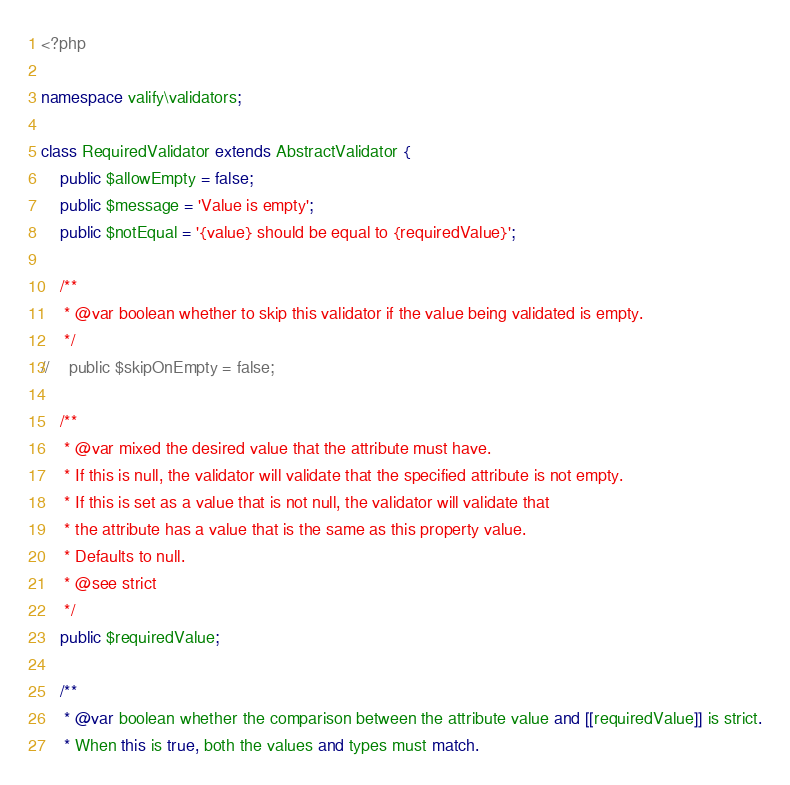<code> <loc_0><loc_0><loc_500><loc_500><_PHP_><?php

namespace valify\validators;

class RequiredValidator extends AbstractValidator {
    public $allowEmpty = false;
    public $message = 'Value is empty';
    public $notEqual = '{value} should be equal to {requiredValue}';

    /**
     * @var boolean whether to skip this validator if the value being validated is empty.
     */
//    public $skipOnEmpty = false;

    /**
     * @var mixed the desired value that the attribute must have.
     * If this is null, the validator will validate that the specified attribute is not empty.
     * If this is set as a value that is not null, the validator will validate that
     * the attribute has a value that is the same as this property value.
     * Defaults to null.
     * @see strict
     */
    public $requiredValue;

    /**
     * @var boolean whether the comparison between the attribute value and [[requiredValue]] is strict.
     * When this is true, both the values and types must match.</code> 